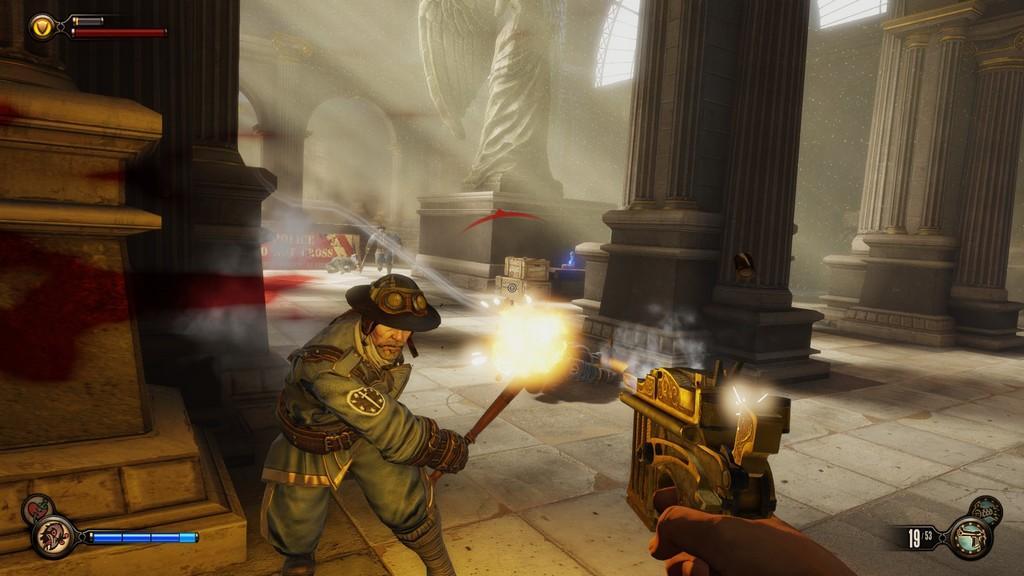Please provide a concise description of this image. This is an animation picture. In this image there are two people holding the objects and running. In the foreground there is a person holding the gun. At the back there are pillars and there is a statue and there are wooden boxes. At the top there is a window. At the bottom there is a floor. 